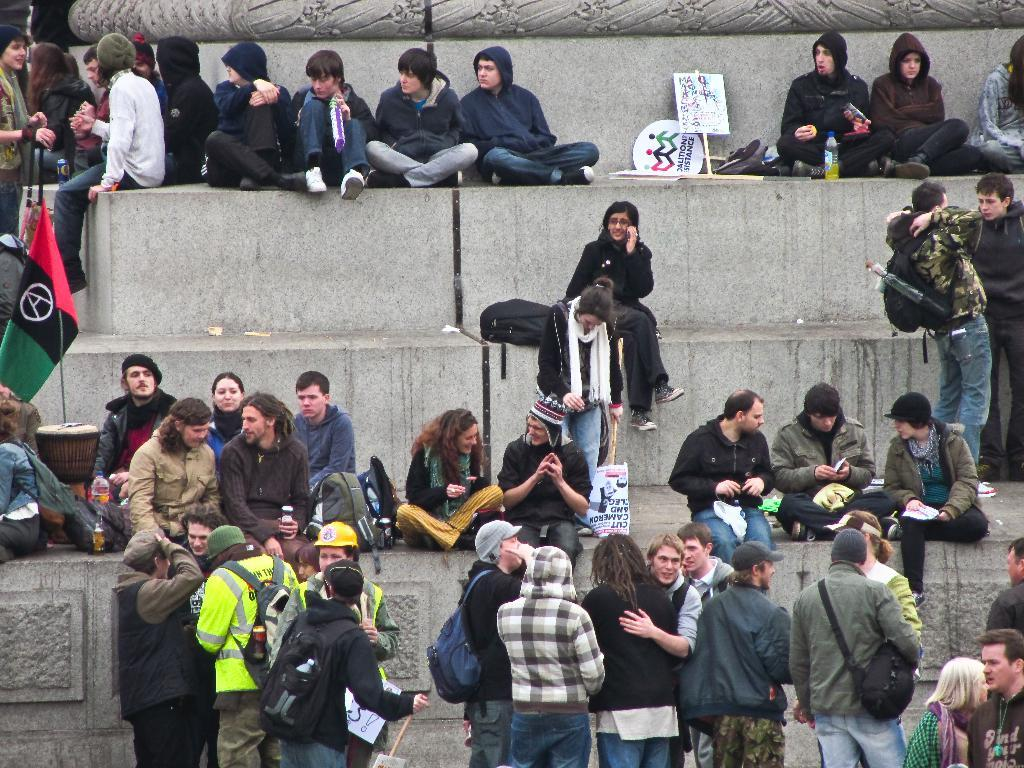What are the people in the image doing? Some people are sitting on the stairs, while others are standing. What objects can be seen in the image besides people? Boards, bottles, and bags are visible in the image. What is the purpose of the boards in the image? The purpose of the boards is not clear from the image, but they could be used for sitting, standing, or as a decorative element. What is the flag in the image used for? The flag in the image could be used for identification, representation, or as a decorative element. What type of rings can be seen on the people's fingers in the image? There are no rings visible on the people's fingers in the image. What color is the dress worn by the person standing on the left side of the image? There is no person wearing a dress in the image. 